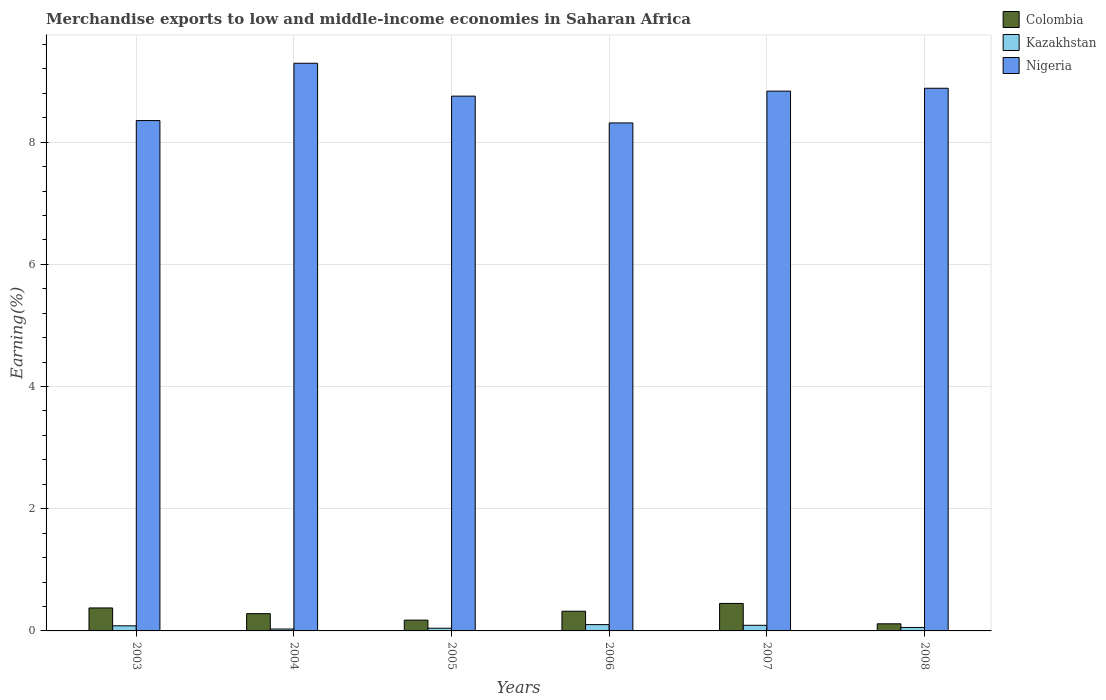How many different coloured bars are there?
Give a very brief answer. 3. Are the number of bars per tick equal to the number of legend labels?
Your response must be concise. Yes. How many bars are there on the 1st tick from the right?
Offer a terse response. 3. In how many cases, is the number of bars for a given year not equal to the number of legend labels?
Make the answer very short. 0. What is the percentage of amount earned from merchandise exports in Kazakhstan in 2004?
Offer a very short reply. 0.03. Across all years, what is the maximum percentage of amount earned from merchandise exports in Kazakhstan?
Offer a terse response. 0.1. Across all years, what is the minimum percentage of amount earned from merchandise exports in Colombia?
Provide a short and direct response. 0.12. In which year was the percentage of amount earned from merchandise exports in Colombia minimum?
Make the answer very short. 2008. What is the total percentage of amount earned from merchandise exports in Colombia in the graph?
Provide a short and direct response. 1.72. What is the difference between the percentage of amount earned from merchandise exports in Nigeria in 2005 and that in 2008?
Give a very brief answer. -0.13. What is the difference between the percentage of amount earned from merchandise exports in Colombia in 2006 and the percentage of amount earned from merchandise exports in Kazakhstan in 2004?
Provide a short and direct response. 0.29. What is the average percentage of amount earned from merchandise exports in Colombia per year?
Your answer should be compact. 0.29. In the year 2003, what is the difference between the percentage of amount earned from merchandise exports in Colombia and percentage of amount earned from merchandise exports in Nigeria?
Offer a terse response. -7.98. In how many years, is the percentage of amount earned from merchandise exports in Nigeria greater than 9.2 %?
Keep it short and to the point. 1. What is the ratio of the percentage of amount earned from merchandise exports in Colombia in 2005 to that in 2007?
Keep it short and to the point. 0.39. Is the percentage of amount earned from merchandise exports in Kazakhstan in 2003 less than that in 2005?
Your response must be concise. No. Is the difference between the percentage of amount earned from merchandise exports in Colombia in 2004 and 2005 greater than the difference between the percentage of amount earned from merchandise exports in Nigeria in 2004 and 2005?
Offer a terse response. No. What is the difference between the highest and the second highest percentage of amount earned from merchandise exports in Kazakhstan?
Your response must be concise. 0.01. What is the difference between the highest and the lowest percentage of amount earned from merchandise exports in Kazakhstan?
Your answer should be compact. 0.07. In how many years, is the percentage of amount earned from merchandise exports in Nigeria greater than the average percentage of amount earned from merchandise exports in Nigeria taken over all years?
Your response must be concise. 4. What does the 3rd bar from the left in 2003 represents?
Give a very brief answer. Nigeria. What does the 3rd bar from the right in 2006 represents?
Provide a succinct answer. Colombia. How many bars are there?
Offer a very short reply. 18. What is the difference between two consecutive major ticks on the Y-axis?
Make the answer very short. 2. Are the values on the major ticks of Y-axis written in scientific E-notation?
Keep it short and to the point. No. Does the graph contain any zero values?
Provide a succinct answer. No. How many legend labels are there?
Provide a short and direct response. 3. What is the title of the graph?
Provide a succinct answer. Merchandise exports to low and middle-income economies in Saharan Africa. What is the label or title of the X-axis?
Offer a terse response. Years. What is the label or title of the Y-axis?
Keep it short and to the point. Earning(%). What is the Earning(%) of Colombia in 2003?
Offer a very short reply. 0.38. What is the Earning(%) in Kazakhstan in 2003?
Offer a terse response. 0.08. What is the Earning(%) of Nigeria in 2003?
Your answer should be very brief. 8.35. What is the Earning(%) in Colombia in 2004?
Give a very brief answer. 0.28. What is the Earning(%) in Kazakhstan in 2004?
Provide a short and direct response. 0.03. What is the Earning(%) of Nigeria in 2004?
Offer a very short reply. 9.29. What is the Earning(%) of Colombia in 2005?
Your answer should be very brief. 0.18. What is the Earning(%) of Kazakhstan in 2005?
Offer a very short reply. 0.04. What is the Earning(%) in Nigeria in 2005?
Your answer should be very brief. 8.75. What is the Earning(%) of Colombia in 2006?
Provide a succinct answer. 0.32. What is the Earning(%) in Kazakhstan in 2006?
Offer a very short reply. 0.1. What is the Earning(%) in Nigeria in 2006?
Keep it short and to the point. 8.31. What is the Earning(%) of Colombia in 2007?
Offer a terse response. 0.45. What is the Earning(%) of Kazakhstan in 2007?
Provide a short and direct response. 0.09. What is the Earning(%) of Nigeria in 2007?
Offer a terse response. 8.83. What is the Earning(%) in Colombia in 2008?
Provide a succinct answer. 0.12. What is the Earning(%) of Kazakhstan in 2008?
Give a very brief answer. 0.06. What is the Earning(%) in Nigeria in 2008?
Offer a very short reply. 8.88. Across all years, what is the maximum Earning(%) in Colombia?
Offer a terse response. 0.45. Across all years, what is the maximum Earning(%) of Kazakhstan?
Your answer should be compact. 0.1. Across all years, what is the maximum Earning(%) in Nigeria?
Provide a short and direct response. 9.29. Across all years, what is the minimum Earning(%) of Colombia?
Your answer should be very brief. 0.12. Across all years, what is the minimum Earning(%) of Kazakhstan?
Make the answer very short. 0.03. Across all years, what is the minimum Earning(%) in Nigeria?
Make the answer very short. 8.31. What is the total Earning(%) of Colombia in the graph?
Your answer should be compact. 1.72. What is the total Earning(%) of Kazakhstan in the graph?
Your answer should be very brief. 0.41. What is the total Earning(%) of Nigeria in the graph?
Your answer should be very brief. 52.43. What is the difference between the Earning(%) in Colombia in 2003 and that in 2004?
Your answer should be compact. 0.09. What is the difference between the Earning(%) in Kazakhstan in 2003 and that in 2004?
Give a very brief answer. 0.05. What is the difference between the Earning(%) of Nigeria in 2003 and that in 2004?
Offer a terse response. -0.94. What is the difference between the Earning(%) of Colombia in 2003 and that in 2005?
Your answer should be compact. 0.2. What is the difference between the Earning(%) of Kazakhstan in 2003 and that in 2005?
Give a very brief answer. 0.04. What is the difference between the Earning(%) of Nigeria in 2003 and that in 2005?
Make the answer very short. -0.4. What is the difference between the Earning(%) in Colombia in 2003 and that in 2006?
Your response must be concise. 0.05. What is the difference between the Earning(%) of Kazakhstan in 2003 and that in 2006?
Your answer should be very brief. -0.02. What is the difference between the Earning(%) in Nigeria in 2003 and that in 2006?
Offer a very short reply. 0.04. What is the difference between the Earning(%) of Colombia in 2003 and that in 2007?
Offer a terse response. -0.07. What is the difference between the Earning(%) in Kazakhstan in 2003 and that in 2007?
Give a very brief answer. -0.01. What is the difference between the Earning(%) of Nigeria in 2003 and that in 2007?
Give a very brief answer. -0.48. What is the difference between the Earning(%) in Colombia in 2003 and that in 2008?
Your response must be concise. 0.26. What is the difference between the Earning(%) of Kazakhstan in 2003 and that in 2008?
Provide a short and direct response. 0.03. What is the difference between the Earning(%) of Nigeria in 2003 and that in 2008?
Your answer should be very brief. -0.53. What is the difference between the Earning(%) in Colombia in 2004 and that in 2005?
Make the answer very short. 0.11. What is the difference between the Earning(%) of Kazakhstan in 2004 and that in 2005?
Give a very brief answer. -0.01. What is the difference between the Earning(%) of Nigeria in 2004 and that in 2005?
Your answer should be compact. 0.54. What is the difference between the Earning(%) of Colombia in 2004 and that in 2006?
Make the answer very short. -0.04. What is the difference between the Earning(%) of Kazakhstan in 2004 and that in 2006?
Offer a very short reply. -0.07. What is the difference between the Earning(%) of Nigeria in 2004 and that in 2006?
Provide a succinct answer. 0.98. What is the difference between the Earning(%) in Colombia in 2004 and that in 2007?
Provide a short and direct response. -0.17. What is the difference between the Earning(%) of Kazakhstan in 2004 and that in 2007?
Offer a very short reply. -0.06. What is the difference between the Earning(%) of Nigeria in 2004 and that in 2007?
Provide a succinct answer. 0.46. What is the difference between the Earning(%) in Colombia in 2004 and that in 2008?
Ensure brevity in your answer.  0.17. What is the difference between the Earning(%) in Kazakhstan in 2004 and that in 2008?
Your answer should be very brief. -0.03. What is the difference between the Earning(%) in Nigeria in 2004 and that in 2008?
Your answer should be compact. 0.41. What is the difference between the Earning(%) in Colombia in 2005 and that in 2006?
Provide a short and direct response. -0.15. What is the difference between the Earning(%) in Kazakhstan in 2005 and that in 2006?
Your answer should be compact. -0.06. What is the difference between the Earning(%) of Nigeria in 2005 and that in 2006?
Keep it short and to the point. 0.44. What is the difference between the Earning(%) of Colombia in 2005 and that in 2007?
Provide a short and direct response. -0.27. What is the difference between the Earning(%) in Kazakhstan in 2005 and that in 2007?
Provide a short and direct response. -0.05. What is the difference between the Earning(%) in Nigeria in 2005 and that in 2007?
Give a very brief answer. -0.08. What is the difference between the Earning(%) in Colombia in 2005 and that in 2008?
Provide a short and direct response. 0.06. What is the difference between the Earning(%) of Kazakhstan in 2005 and that in 2008?
Offer a terse response. -0.01. What is the difference between the Earning(%) in Nigeria in 2005 and that in 2008?
Your answer should be compact. -0.13. What is the difference between the Earning(%) in Colombia in 2006 and that in 2007?
Make the answer very short. -0.13. What is the difference between the Earning(%) in Kazakhstan in 2006 and that in 2007?
Make the answer very short. 0.01. What is the difference between the Earning(%) of Nigeria in 2006 and that in 2007?
Provide a succinct answer. -0.52. What is the difference between the Earning(%) of Colombia in 2006 and that in 2008?
Keep it short and to the point. 0.21. What is the difference between the Earning(%) in Kazakhstan in 2006 and that in 2008?
Offer a very short reply. 0.05. What is the difference between the Earning(%) in Nigeria in 2006 and that in 2008?
Offer a terse response. -0.57. What is the difference between the Earning(%) in Colombia in 2007 and that in 2008?
Your response must be concise. 0.33. What is the difference between the Earning(%) of Kazakhstan in 2007 and that in 2008?
Offer a very short reply. 0.04. What is the difference between the Earning(%) of Nigeria in 2007 and that in 2008?
Your response must be concise. -0.05. What is the difference between the Earning(%) of Colombia in 2003 and the Earning(%) of Kazakhstan in 2004?
Keep it short and to the point. 0.35. What is the difference between the Earning(%) of Colombia in 2003 and the Earning(%) of Nigeria in 2004?
Offer a very short reply. -8.92. What is the difference between the Earning(%) of Kazakhstan in 2003 and the Earning(%) of Nigeria in 2004?
Offer a very short reply. -9.21. What is the difference between the Earning(%) of Colombia in 2003 and the Earning(%) of Kazakhstan in 2005?
Provide a short and direct response. 0.33. What is the difference between the Earning(%) in Colombia in 2003 and the Earning(%) in Nigeria in 2005?
Offer a very short reply. -8.38. What is the difference between the Earning(%) of Kazakhstan in 2003 and the Earning(%) of Nigeria in 2005?
Offer a terse response. -8.67. What is the difference between the Earning(%) in Colombia in 2003 and the Earning(%) in Kazakhstan in 2006?
Your answer should be very brief. 0.27. What is the difference between the Earning(%) of Colombia in 2003 and the Earning(%) of Nigeria in 2006?
Provide a succinct answer. -7.94. What is the difference between the Earning(%) in Kazakhstan in 2003 and the Earning(%) in Nigeria in 2006?
Your answer should be very brief. -8.23. What is the difference between the Earning(%) of Colombia in 2003 and the Earning(%) of Kazakhstan in 2007?
Offer a terse response. 0.28. What is the difference between the Earning(%) in Colombia in 2003 and the Earning(%) in Nigeria in 2007?
Make the answer very short. -8.46. What is the difference between the Earning(%) in Kazakhstan in 2003 and the Earning(%) in Nigeria in 2007?
Offer a very short reply. -8.75. What is the difference between the Earning(%) of Colombia in 2003 and the Earning(%) of Kazakhstan in 2008?
Keep it short and to the point. 0.32. What is the difference between the Earning(%) in Colombia in 2003 and the Earning(%) in Nigeria in 2008?
Offer a terse response. -8.51. What is the difference between the Earning(%) of Kazakhstan in 2003 and the Earning(%) of Nigeria in 2008?
Your answer should be compact. -8.8. What is the difference between the Earning(%) in Colombia in 2004 and the Earning(%) in Kazakhstan in 2005?
Ensure brevity in your answer.  0.24. What is the difference between the Earning(%) of Colombia in 2004 and the Earning(%) of Nigeria in 2005?
Keep it short and to the point. -8.47. What is the difference between the Earning(%) in Kazakhstan in 2004 and the Earning(%) in Nigeria in 2005?
Give a very brief answer. -8.72. What is the difference between the Earning(%) of Colombia in 2004 and the Earning(%) of Kazakhstan in 2006?
Give a very brief answer. 0.18. What is the difference between the Earning(%) in Colombia in 2004 and the Earning(%) in Nigeria in 2006?
Offer a very short reply. -8.03. What is the difference between the Earning(%) in Kazakhstan in 2004 and the Earning(%) in Nigeria in 2006?
Keep it short and to the point. -8.28. What is the difference between the Earning(%) of Colombia in 2004 and the Earning(%) of Kazakhstan in 2007?
Offer a very short reply. 0.19. What is the difference between the Earning(%) of Colombia in 2004 and the Earning(%) of Nigeria in 2007?
Offer a terse response. -8.55. What is the difference between the Earning(%) in Kazakhstan in 2004 and the Earning(%) in Nigeria in 2007?
Provide a short and direct response. -8.8. What is the difference between the Earning(%) in Colombia in 2004 and the Earning(%) in Kazakhstan in 2008?
Give a very brief answer. 0.23. What is the difference between the Earning(%) of Colombia in 2004 and the Earning(%) of Nigeria in 2008?
Provide a succinct answer. -8.6. What is the difference between the Earning(%) of Kazakhstan in 2004 and the Earning(%) of Nigeria in 2008?
Offer a very short reply. -8.85. What is the difference between the Earning(%) in Colombia in 2005 and the Earning(%) in Kazakhstan in 2006?
Provide a short and direct response. 0.07. What is the difference between the Earning(%) of Colombia in 2005 and the Earning(%) of Nigeria in 2006?
Make the answer very short. -8.14. What is the difference between the Earning(%) of Kazakhstan in 2005 and the Earning(%) of Nigeria in 2006?
Make the answer very short. -8.27. What is the difference between the Earning(%) of Colombia in 2005 and the Earning(%) of Kazakhstan in 2007?
Provide a succinct answer. 0.08. What is the difference between the Earning(%) of Colombia in 2005 and the Earning(%) of Nigeria in 2007?
Give a very brief answer. -8.66. What is the difference between the Earning(%) in Kazakhstan in 2005 and the Earning(%) in Nigeria in 2007?
Your answer should be very brief. -8.79. What is the difference between the Earning(%) in Colombia in 2005 and the Earning(%) in Kazakhstan in 2008?
Make the answer very short. 0.12. What is the difference between the Earning(%) in Colombia in 2005 and the Earning(%) in Nigeria in 2008?
Provide a short and direct response. -8.71. What is the difference between the Earning(%) in Kazakhstan in 2005 and the Earning(%) in Nigeria in 2008?
Ensure brevity in your answer.  -8.84. What is the difference between the Earning(%) in Colombia in 2006 and the Earning(%) in Kazakhstan in 2007?
Offer a terse response. 0.23. What is the difference between the Earning(%) in Colombia in 2006 and the Earning(%) in Nigeria in 2007?
Your answer should be very brief. -8.51. What is the difference between the Earning(%) of Kazakhstan in 2006 and the Earning(%) of Nigeria in 2007?
Your response must be concise. -8.73. What is the difference between the Earning(%) of Colombia in 2006 and the Earning(%) of Kazakhstan in 2008?
Offer a very short reply. 0.27. What is the difference between the Earning(%) of Colombia in 2006 and the Earning(%) of Nigeria in 2008?
Make the answer very short. -8.56. What is the difference between the Earning(%) of Kazakhstan in 2006 and the Earning(%) of Nigeria in 2008?
Ensure brevity in your answer.  -8.78. What is the difference between the Earning(%) of Colombia in 2007 and the Earning(%) of Kazakhstan in 2008?
Give a very brief answer. 0.39. What is the difference between the Earning(%) of Colombia in 2007 and the Earning(%) of Nigeria in 2008?
Provide a short and direct response. -8.43. What is the difference between the Earning(%) of Kazakhstan in 2007 and the Earning(%) of Nigeria in 2008?
Keep it short and to the point. -8.79. What is the average Earning(%) of Colombia per year?
Provide a succinct answer. 0.29. What is the average Earning(%) in Kazakhstan per year?
Ensure brevity in your answer.  0.07. What is the average Earning(%) in Nigeria per year?
Make the answer very short. 8.74. In the year 2003, what is the difference between the Earning(%) of Colombia and Earning(%) of Kazakhstan?
Provide a succinct answer. 0.29. In the year 2003, what is the difference between the Earning(%) in Colombia and Earning(%) in Nigeria?
Give a very brief answer. -7.98. In the year 2003, what is the difference between the Earning(%) of Kazakhstan and Earning(%) of Nigeria?
Provide a succinct answer. -8.27. In the year 2004, what is the difference between the Earning(%) of Colombia and Earning(%) of Kazakhstan?
Your response must be concise. 0.25. In the year 2004, what is the difference between the Earning(%) of Colombia and Earning(%) of Nigeria?
Keep it short and to the point. -9.01. In the year 2004, what is the difference between the Earning(%) of Kazakhstan and Earning(%) of Nigeria?
Ensure brevity in your answer.  -9.26. In the year 2005, what is the difference between the Earning(%) in Colombia and Earning(%) in Kazakhstan?
Your answer should be compact. 0.13. In the year 2005, what is the difference between the Earning(%) in Colombia and Earning(%) in Nigeria?
Give a very brief answer. -8.58. In the year 2005, what is the difference between the Earning(%) in Kazakhstan and Earning(%) in Nigeria?
Make the answer very short. -8.71. In the year 2006, what is the difference between the Earning(%) in Colombia and Earning(%) in Kazakhstan?
Keep it short and to the point. 0.22. In the year 2006, what is the difference between the Earning(%) in Colombia and Earning(%) in Nigeria?
Give a very brief answer. -7.99. In the year 2006, what is the difference between the Earning(%) of Kazakhstan and Earning(%) of Nigeria?
Offer a very short reply. -8.21. In the year 2007, what is the difference between the Earning(%) of Colombia and Earning(%) of Kazakhstan?
Make the answer very short. 0.36. In the year 2007, what is the difference between the Earning(%) of Colombia and Earning(%) of Nigeria?
Provide a succinct answer. -8.39. In the year 2007, what is the difference between the Earning(%) of Kazakhstan and Earning(%) of Nigeria?
Offer a very short reply. -8.74. In the year 2008, what is the difference between the Earning(%) in Colombia and Earning(%) in Kazakhstan?
Make the answer very short. 0.06. In the year 2008, what is the difference between the Earning(%) of Colombia and Earning(%) of Nigeria?
Offer a terse response. -8.77. In the year 2008, what is the difference between the Earning(%) in Kazakhstan and Earning(%) in Nigeria?
Your response must be concise. -8.83. What is the ratio of the Earning(%) in Colombia in 2003 to that in 2004?
Give a very brief answer. 1.33. What is the ratio of the Earning(%) of Kazakhstan in 2003 to that in 2004?
Offer a very short reply. 2.7. What is the ratio of the Earning(%) in Nigeria in 2003 to that in 2004?
Ensure brevity in your answer.  0.9. What is the ratio of the Earning(%) of Colombia in 2003 to that in 2005?
Offer a very short reply. 2.13. What is the ratio of the Earning(%) in Kazakhstan in 2003 to that in 2005?
Provide a succinct answer. 1.88. What is the ratio of the Earning(%) of Nigeria in 2003 to that in 2005?
Your answer should be compact. 0.95. What is the ratio of the Earning(%) of Colombia in 2003 to that in 2006?
Keep it short and to the point. 1.17. What is the ratio of the Earning(%) in Kazakhstan in 2003 to that in 2006?
Your response must be concise. 0.81. What is the ratio of the Earning(%) in Nigeria in 2003 to that in 2006?
Offer a terse response. 1. What is the ratio of the Earning(%) of Colombia in 2003 to that in 2007?
Give a very brief answer. 0.84. What is the ratio of the Earning(%) of Kazakhstan in 2003 to that in 2007?
Your answer should be very brief. 0.91. What is the ratio of the Earning(%) of Nigeria in 2003 to that in 2007?
Make the answer very short. 0.95. What is the ratio of the Earning(%) in Colombia in 2003 to that in 2008?
Your answer should be compact. 3.23. What is the ratio of the Earning(%) in Kazakhstan in 2003 to that in 2008?
Ensure brevity in your answer.  1.48. What is the ratio of the Earning(%) in Nigeria in 2003 to that in 2008?
Make the answer very short. 0.94. What is the ratio of the Earning(%) of Colombia in 2004 to that in 2005?
Ensure brevity in your answer.  1.6. What is the ratio of the Earning(%) of Kazakhstan in 2004 to that in 2005?
Ensure brevity in your answer.  0.7. What is the ratio of the Earning(%) in Nigeria in 2004 to that in 2005?
Ensure brevity in your answer.  1.06. What is the ratio of the Earning(%) in Colombia in 2004 to that in 2006?
Your response must be concise. 0.88. What is the ratio of the Earning(%) of Kazakhstan in 2004 to that in 2006?
Offer a very short reply. 0.3. What is the ratio of the Earning(%) of Nigeria in 2004 to that in 2006?
Offer a terse response. 1.12. What is the ratio of the Earning(%) in Colombia in 2004 to that in 2007?
Provide a succinct answer. 0.63. What is the ratio of the Earning(%) of Kazakhstan in 2004 to that in 2007?
Keep it short and to the point. 0.34. What is the ratio of the Earning(%) in Nigeria in 2004 to that in 2007?
Provide a succinct answer. 1.05. What is the ratio of the Earning(%) in Colombia in 2004 to that in 2008?
Your answer should be compact. 2.43. What is the ratio of the Earning(%) of Kazakhstan in 2004 to that in 2008?
Offer a terse response. 0.55. What is the ratio of the Earning(%) in Nigeria in 2004 to that in 2008?
Offer a very short reply. 1.05. What is the ratio of the Earning(%) of Colombia in 2005 to that in 2006?
Offer a very short reply. 0.55. What is the ratio of the Earning(%) of Kazakhstan in 2005 to that in 2006?
Offer a terse response. 0.43. What is the ratio of the Earning(%) in Nigeria in 2005 to that in 2006?
Provide a succinct answer. 1.05. What is the ratio of the Earning(%) of Colombia in 2005 to that in 2007?
Offer a terse response. 0.39. What is the ratio of the Earning(%) of Kazakhstan in 2005 to that in 2007?
Your answer should be compact. 0.48. What is the ratio of the Earning(%) of Nigeria in 2005 to that in 2007?
Your answer should be very brief. 0.99. What is the ratio of the Earning(%) of Colombia in 2005 to that in 2008?
Ensure brevity in your answer.  1.52. What is the ratio of the Earning(%) in Kazakhstan in 2005 to that in 2008?
Provide a succinct answer. 0.79. What is the ratio of the Earning(%) of Nigeria in 2005 to that in 2008?
Ensure brevity in your answer.  0.99. What is the ratio of the Earning(%) in Colombia in 2006 to that in 2007?
Offer a very short reply. 0.72. What is the ratio of the Earning(%) of Kazakhstan in 2006 to that in 2007?
Make the answer very short. 1.12. What is the ratio of the Earning(%) of Nigeria in 2006 to that in 2007?
Your answer should be compact. 0.94. What is the ratio of the Earning(%) of Colombia in 2006 to that in 2008?
Keep it short and to the point. 2.77. What is the ratio of the Earning(%) in Kazakhstan in 2006 to that in 2008?
Your response must be concise. 1.82. What is the ratio of the Earning(%) in Nigeria in 2006 to that in 2008?
Provide a short and direct response. 0.94. What is the ratio of the Earning(%) of Colombia in 2007 to that in 2008?
Provide a succinct answer. 3.86. What is the ratio of the Earning(%) of Kazakhstan in 2007 to that in 2008?
Your answer should be compact. 1.63. What is the difference between the highest and the second highest Earning(%) of Colombia?
Keep it short and to the point. 0.07. What is the difference between the highest and the second highest Earning(%) in Kazakhstan?
Provide a short and direct response. 0.01. What is the difference between the highest and the second highest Earning(%) in Nigeria?
Your answer should be very brief. 0.41. What is the difference between the highest and the lowest Earning(%) of Colombia?
Make the answer very short. 0.33. What is the difference between the highest and the lowest Earning(%) of Kazakhstan?
Ensure brevity in your answer.  0.07. What is the difference between the highest and the lowest Earning(%) of Nigeria?
Provide a succinct answer. 0.98. 